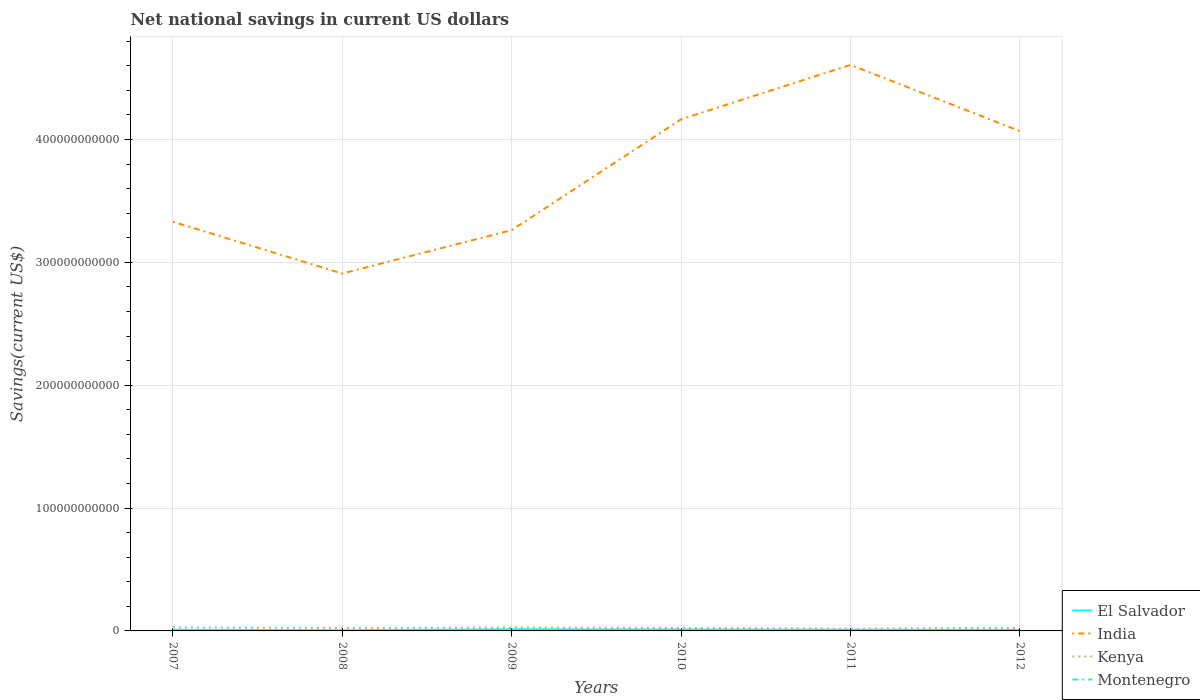Does the line corresponding to El Salvador intersect with the line corresponding to Montenegro?
Offer a terse response. No. Is the number of lines equal to the number of legend labels?
Provide a succinct answer. No. Across all years, what is the maximum net national savings in India?
Make the answer very short. 2.91e+11. What is the total net national savings in India in the graph?
Provide a succinct answer. 6.84e+09. What is the difference between the highest and the second highest net national savings in India?
Provide a succinct answer. 1.70e+11. How many lines are there?
Your answer should be very brief. 3. How many years are there in the graph?
Keep it short and to the point. 6. What is the difference between two consecutive major ticks on the Y-axis?
Provide a succinct answer. 1.00e+11. Does the graph contain any zero values?
Ensure brevity in your answer.  Yes. Does the graph contain grids?
Provide a short and direct response. Yes. How are the legend labels stacked?
Provide a succinct answer. Vertical. What is the title of the graph?
Provide a short and direct response. Net national savings in current US dollars. Does "Cyprus" appear as one of the legend labels in the graph?
Provide a succinct answer. No. What is the label or title of the X-axis?
Offer a terse response. Years. What is the label or title of the Y-axis?
Provide a succinct answer. Savings(current US$). What is the Savings(current US$) in El Salvador in 2007?
Offer a terse response. 9.61e+08. What is the Savings(current US$) of India in 2007?
Make the answer very short. 3.33e+11. What is the Savings(current US$) of Kenya in 2007?
Provide a succinct answer. 2.90e+09. What is the Savings(current US$) in Montenegro in 2007?
Offer a terse response. 0. What is the Savings(current US$) of El Salvador in 2008?
Your answer should be very brief. 5.68e+08. What is the Savings(current US$) of India in 2008?
Offer a terse response. 2.91e+11. What is the Savings(current US$) of Kenya in 2008?
Offer a terse response. 2.40e+09. What is the Savings(current US$) in Montenegro in 2008?
Your answer should be compact. 0. What is the Savings(current US$) in El Salvador in 2009?
Provide a short and direct response. 1.40e+09. What is the Savings(current US$) in India in 2009?
Provide a short and direct response. 3.26e+11. What is the Savings(current US$) in Kenya in 2009?
Offer a very short reply. 2.76e+09. What is the Savings(current US$) of Montenegro in 2009?
Keep it short and to the point. 0. What is the Savings(current US$) in El Salvador in 2010?
Give a very brief answer. 1.19e+09. What is the Savings(current US$) in India in 2010?
Give a very brief answer. 4.16e+11. What is the Savings(current US$) in Kenya in 2010?
Your response must be concise. 2.49e+09. What is the Savings(current US$) of El Salvador in 2011?
Your answer should be compact. 9.87e+08. What is the Savings(current US$) of India in 2011?
Ensure brevity in your answer.  4.61e+11. What is the Savings(current US$) of Kenya in 2011?
Your response must be concise. 1.82e+09. What is the Savings(current US$) in Montenegro in 2011?
Keep it short and to the point. 0. What is the Savings(current US$) of El Salvador in 2012?
Provide a succinct answer. 8.30e+08. What is the Savings(current US$) in India in 2012?
Keep it short and to the point. 4.07e+11. What is the Savings(current US$) in Kenya in 2012?
Your response must be concise. 2.45e+09. Across all years, what is the maximum Savings(current US$) of El Salvador?
Your answer should be compact. 1.40e+09. Across all years, what is the maximum Savings(current US$) in India?
Provide a succinct answer. 4.61e+11. Across all years, what is the maximum Savings(current US$) in Kenya?
Make the answer very short. 2.90e+09. Across all years, what is the minimum Savings(current US$) of El Salvador?
Provide a short and direct response. 5.68e+08. Across all years, what is the minimum Savings(current US$) in India?
Give a very brief answer. 2.91e+11. Across all years, what is the minimum Savings(current US$) of Kenya?
Make the answer very short. 1.82e+09. What is the total Savings(current US$) of El Salvador in the graph?
Make the answer very short. 5.94e+09. What is the total Savings(current US$) in India in the graph?
Your answer should be very brief. 2.23e+12. What is the total Savings(current US$) of Kenya in the graph?
Your answer should be very brief. 1.48e+1. What is the difference between the Savings(current US$) in El Salvador in 2007 and that in 2008?
Offer a very short reply. 3.92e+08. What is the difference between the Savings(current US$) in India in 2007 and that in 2008?
Ensure brevity in your answer.  4.22e+1. What is the difference between the Savings(current US$) of Kenya in 2007 and that in 2008?
Give a very brief answer. 4.98e+08. What is the difference between the Savings(current US$) in El Salvador in 2007 and that in 2009?
Your answer should be very brief. -4.41e+08. What is the difference between the Savings(current US$) of India in 2007 and that in 2009?
Provide a short and direct response. 6.84e+09. What is the difference between the Savings(current US$) of Kenya in 2007 and that in 2009?
Ensure brevity in your answer.  1.35e+08. What is the difference between the Savings(current US$) in El Salvador in 2007 and that in 2010?
Offer a very short reply. -2.31e+08. What is the difference between the Savings(current US$) of India in 2007 and that in 2010?
Your answer should be compact. -8.34e+1. What is the difference between the Savings(current US$) in Kenya in 2007 and that in 2010?
Your response must be concise. 4.04e+08. What is the difference between the Savings(current US$) in El Salvador in 2007 and that in 2011?
Ensure brevity in your answer.  -2.62e+07. What is the difference between the Savings(current US$) in India in 2007 and that in 2011?
Your answer should be very brief. -1.28e+11. What is the difference between the Savings(current US$) in Kenya in 2007 and that in 2011?
Your response must be concise. 1.08e+09. What is the difference between the Savings(current US$) of El Salvador in 2007 and that in 2012?
Your response must be concise. 1.30e+08. What is the difference between the Savings(current US$) of India in 2007 and that in 2012?
Your answer should be compact. -7.38e+1. What is the difference between the Savings(current US$) in Kenya in 2007 and that in 2012?
Your answer should be very brief. 4.46e+08. What is the difference between the Savings(current US$) in El Salvador in 2008 and that in 2009?
Make the answer very short. -8.33e+08. What is the difference between the Savings(current US$) in India in 2008 and that in 2009?
Keep it short and to the point. -3.53e+1. What is the difference between the Savings(current US$) in Kenya in 2008 and that in 2009?
Give a very brief answer. -3.62e+08. What is the difference between the Savings(current US$) in El Salvador in 2008 and that in 2010?
Offer a terse response. -6.24e+08. What is the difference between the Savings(current US$) of India in 2008 and that in 2010?
Your response must be concise. -1.26e+11. What is the difference between the Savings(current US$) in Kenya in 2008 and that in 2010?
Keep it short and to the point. -9.36e+07. What is the difference between the Savings(current US$) of El Salvador in 2008 and that in 2011?
Ensure brevity in your answer.  -4.18e+08. What is the difference between the Savings(current US$) in India in 2008 and that in 2011?
Give a very brief answer. -1.70e+11. What is the difference between the Savings(current US$) in Kenya in 2008 and that in 2011?
Give a very brief answer. 5.79e+08. What is the difference between the Savings(current US$) of El Salvador in 2008 and that in 2012?
Your answer should be very brief. -2.62e+08. What is the difference between the Savings(current US$) in India in 2008 and that in 2012?
Give a very brief answer. -1.16e+11. What is the difference between the Savings(current US$) in Kenya in 2008 and that in 2012?
Your answer should be compact. -5.17e+07. What is the difference between the Savings(current US$) of El Salvador in 2009 and that in 2010?
Make the answer very short. 2.10e+08. What is the difference between the Savings(current US$) of India in 2009 and that in 2010?
Your answer should be very brief. -9.02e+1. What is the difference between the Savings(current US$) in Kenya in 2009 and that in 2010?
Offer a terse response. 2.69e+08. What is the difference between the Savings(current US$) of El Salvador in 2009 and that in 2011?
Ensure brevity in your answer.  4.15e+08. What is the difference between the Savings(current US$) of India in 2009 and that in 2011?
Give a very brief answer. -1.34e+11. What is the difference between the Savings(current US$) of Kenya in 2009 and that in 2011?
Keep it short and to the point. 9.41e+08. What is the difference between the Savings(current US$) of El Salvador in 2009 and that in 2012?
Provide a short and direct response. 5.71e+08. What is the difference between the Savings(current US$) of India in 2009 and that in 2012?
Give a very brief answer. -8.06e+1. What is the difference between the Savings(current US$) of Kenya in 2009 and that in 2012?
Your answer should be very brief. 3.11e+08. What is the difference between the Savings(current US$) of El Salvador in 2010 and that in 2011?
Give a very brief answer. 2.05e+08. What is the difference between the Savings(current US$) in India in 2010 and that in 2011?
Your response must be concise. -4.42e+1. What is the difference between the Savings(current US$) in Kenya in 2010 and that in 2011?
Keep it short and to the point. 6.72e+08. What is the difference between the Savings(current US$) in El Salvador in 2010 and that in 2012?
Offer a terse response. 3.62e+08. What is the difference between the Savings(current US$) of India in 2010 and that in 2012?
Your response must be concise. 9.64e+09. What is the difference between the Savings(current US$) in Kenya in 2010 and that in 2012?
Your answer should be compact. 4.19e+07. What is the difference between the Savings(current US$) of El Salvador in 2011 and that in 2012?
Provide a short and direct response. 1.56e+08. What is the difference between the Savings(current US$) of India in 2011 and that in 2012?
Offer a terse response. 5.39e+1. What is the difference between the Savings(current US$) in Kenya in 2011 and that in 2012?
Ensure brevity in your answer.  -6.30e+08. What is the difference between the Savings(current US$) of El Salvador in 2007 and the Savings(current US$) of India in 2008?
Ensure brevity in your answer.  -2.90e+11. What is the difference between the Savings(current US$) in El Salvador in 2007 and the Savings(current US$) in Kenya in 2008?
Provide a short and direct response. -1.44e+09. What is the difference between the Savings(current US$) of India in 2007 and the Savings(current US$) of Kenya in 2008?
Provide a succinct answer. 3.31e+11. What is the difference between the Savings(current US$) in El Salvador in 2007 and the Savings(current US$) in India in 2009?
Offer a very short reply. -3.25e+11. What is the difference between the Savings(current US$) of El Salvador in 2007 and the Savings(current US$) of Kenya in 2009?
Your response must be concise. -1.80e+09. What is the difference between the Savings(current US$) of India in 2007 and the Savings(current US$) of Kenya in 2009?
Offer a very short reply. 3.30e+11. What is the difference between the Savings(current US$) in El Salvador in 2007 and the Savings(current US$) in India in 2010?
Give a very brief answer. -4.16e+11. What is the difference between the Savings(current US$) of El Salvador in 2007 and the Savings(current US$) of Kenya in 2010?
Provide a succinct answer. -1.53e+09. What is the difference between the Savings(current US$) in India in 2007 and the Savings(current US$) in Kenya in 2010?
Provide a short and direct response. 3.31e+11. What is the difference between the Savings(current US$) of El Salvador in 2007 and the Savings(current US$) of India in 2011?
Make the answer very short. -4.60e+11. What is the difference between the Savings(current US$) in El Salvador in 2007 and the Savings(current US$) in Kenya in 2011?
Your response must be concise. -8.58e+08. What is the difference between the Savings(current US$) of India in 2007 and the Savings(current US$) of Kenya in 2011?
Give a very brief answer. 3.31e+11. What is the difference between the Savings(current US$) of El Salvador in 2007 and the Savings(current US$) of India in 2012?
Provide a short and direct response. -4.06e+11. What is the difference between the Savings(current US$) in El Salvador in 2007 and the Savings(current US$) in Kenya in 2012?
Offer a very short reply. -1.49e+09. What is the difference between the Savings(current US$) of India in 2007 and the Savings(current US$) of Kenya in 2012?
Your response must be concise. 3.31e+11. What is the difference between the Savings(current US$) in El Salvador in 2008 and the Savings(current US$) in India in 2009?
Offer a terse response. -3.26e+11. What is the difference between the Savings(current US$) in El Salvador in 2008 and the Savings(current US$) in Kenya in 2009?
Make the answer very short. -2.19e+09. What is the difference between the Savings(current US$) in India in 2008 and the Savings(current US$) in Kenya in 2009?
Provide a short and direct response. 2.88e+11. What is the difference between the Savings(current US$) of El Salvador in 2008 and the Savings(current US$) of India in 2010?
Provide a succinct answer. -4.16e+11. What is the difference between the Savings(current US$) of El Salvador in 2008 and the Savings(current US$) of Kenya in 2010?
Offer a very short reply. -1.92e+09. What is the difference between the Savings(current US$) of India in 2008 and the Savings(current US$) of Kenya in 2010?
Your answer should be compact. 2.88e+11. What is the difference between the Savings(current US$) of El Salvador in 2008 and the Savings(current US$) of India in 2011?
Give a very brief answer. -4.60e+11. What is the difference between the Savings(current US$) of El Salvador in 2008 and the Savings(current US$) of Kenya in 2011?
Provide a short and direct response. -1.25e+09. What is the difference between the Savings(current US$) of India in 2008 and the Savings(current US$) of Kenya in 2011?
Ensure brevity in your answer.  2.89e+11. What is the difference between the Savings(current US$) in El Salvador in 2008 and the Savings(current US$) in India in 2012?
Make the answer very short. -4.06e+11. What is the difference between the Savings(current US$) of El Salvador in 2008 and the Savings(current US$) of Kenya in 2012?
Offer a terse response. -1.88e+09. What is the difference between the Savings(current US$) of India in 2008 and the Savings(current US$) of Kenya in 2012?
Provide a succinct answer. 2.88e+11. What is the difference between the Savings(current US$) in El Salvador in 2009 and the Savings(current US$) in India in 2010?
Offer a very short reply. -4.15e+11. What is the difference between the Savings(current US$) in El Salvador in 2009 and the Savings(current US$) in Kenya in 2010?
Ensure brevity in your answer.  -1.09e+09. What is the difference between the Savings(current US$) of India in 2009 and the Savings(current US$) of Kenya in 2010?
Keep it short and to the point. 3.24e+11. What is the difference between the Savings(current US$) in El Salvador in 2009 and the Savings(current US$) in India in 2011?
Offer a terse response. -4.59e+11. What is the difference between the Savings(current US$) in El Salvador in 2009 and the Savings(current US$) in Kenya in 2011?
Make the answer very short. -4.17e+08. What is the difference between the Savings(current US$) of India in 2009 and the Savings(current US$) of Kenya in 2011?
Provide a succinct answer. 3.24e+11. What is the difference between the Savings(current US$) in El Salvador in 2009 and the Savings(current US$) in India in 2012?
Your answer should be very brief. -4.05e+11. What is the difference between the Savings(current US$) of El Salvador in 2009 and the Savings(current US$) of Kenya in 2012?
Offer a terse response. -1.05e+09. What is the difference between the Savings(current US$) in India in 2009 and the Savings(current US$) in Kenya in 2012?
Ensure brevity in your answer.  3.24e+11. What is the difference between the Savings(current US$) in El Salvador in 2010 and the Savings(current US$) in India in 2011?
Provide a short and direct response. -4.60e+11. What is the difference between the Savings(current US$) of El Salvador in 2010 and the Savings(current US$) of Kenya in 2011?
Keep it short and to the point. -6.27e+08. What is the difference between the Savings(current US$) of India in 2010 and the Savings(current US$) of Kenya in 2011?
Your answer should be very brief. 4.15e+11. What is the difference between the Savings(current US$) of El Salvador in 2010 and the Savings(current US$) of India in 2012?
Give a very brief answer. -4.06e+11. What is the difference between the Savings(current US$) of El Salvador in 2010 and the Savings(current US$) of Kenya in 2012?
Your response must be concise. -1.26e+09. What is the difference between the Savings(current US$) of India in 2010 and the Savings(current US$) of Kenya in 2012?
Give a very brief answer. 4.14e+11. What is the difference between the Savings(current US$) in El Salvador in 2011 and the Savings(current US$) in India in 2012?
Keep it short and to the point. -4.06e+11. What is the difference between the Savings(current US$) of El Salvador in 2011 and the Savings(current US$) of Kenya in 2012?
Your answer should be compact. -1.46e+09. What is the difference between the Savings(current US$) in India in 2011 and the Savings(current US$) in Kenya in 2012?
Your response must be concise. 4.58e+11. What is the average Savings(current US$) in El Salvador per year?
Ensure brevity in your answer.  9.90e+08. What is the average Savings(current US$) of India per year?
Your response must be concise. 3.72e+11. What is the average Savings(current US$) in Kenya per year?
Your answer should be very brief. 2.47e+09. What is the average Savings(current US$) in Montenegro per year?
Keep it short and to the point. 0. In the year 2007, what is the difference between the Savings(current US$) of El Salvador and Savings(current US$) of India?
Your response must be concise. -3.32e+11. In the year 2007, what is the difference between the Savings(current US$) in El Salvador and Savings(current US$) in Kenya?
Offer a terse response. -1.93e+09. In the year 2007, what is the difference between the Savings(current US$) of India and Savings(current US$) of Kenya?
Provide a short and direct response. 3.30e+11. In the year 2008, what is the difference between the Savings(current US$) of El Salvador and Savings(current US$) of India?
Your answer should be compact. -2.90e+11. In the year 2008, what is the difference between the Savings(current US$) of El Salvador and Savings(current US$) of Kenya?
Your response must be concise. -1.83e+09. In the year 2008, what is the difference between the Savings(current US$) of India and Savings(current US$) of Kenya?
Provide a short and direct response. 2.89e+11. In the year 2009, what is the difference between the Savings(current US$) in El Salvador and Savings(current US$) in India?
Provide a short and direct response. -3.25e+11. In the year 2009, what is the difference between the Savings(current US$) in El Salvador and Savings(current US$) in Kenya?
Make the answer very short. -1.36e+09. In the year 2009, what is the difference between the Savings(current US$) in India and Savings(current US$) in Kenya?
Provide a succinct answer. 3.23e+11. In the year 2010, what is the difference between the Savings(current US$) of El Salvador and Savings(current US$) of India?
Provide a succinct answer. -4.15e+11. In the year 2010, what is the difference between the Savings(current US$) in El Salvador and Savings(current US$) in Kenya?
Provide a short and direct response. -1.30e+09. In the year 2010, what is the difference between the Savings(current US$) in India and Savings(current US$) in Kenya?
Your response must be concise. 4.14e+11. In the year 2011, what is the difference between the Savings(current US$) in El Salvador and Savings(current US$) in India?
Keep it short and to the point. -4.60e+11. In the year 2011, what is the difference between the Savings(current US$) of El Salvador and Savings(current US$) of Kenya?
Provide a short and direct response. -8.32e+08. In the year 2011, what is the difference between the Savings(current US$) in India and Savings(current US$) in Kenya?
Provide a succinct answer. 4.59e+11. In the year 2012, what is the difference between the Savings(current US$) of El Salvador and Savings(current US$) of India?
Provide a short and direct response. -4.06e+11. In the year 2012, what is the difference between the Savings(current US$) of El Salvador and Savings(current US$) of Kenya?
Offer a terse response. -1.62e+09. In the year 2012, what is the difference between the Savings(current US$) of India and Savings(current US$) of Kenya?
Provide a short and direct response. 4.04e+11. What is the ratio of the Savings(current US$) in El Salvador in 2007 to that in 2008?
Make the answer very short. 1.69. What is the ratio of the Savings(current US$) in India in 2007 to that in 2008?
Offer a very short reply. 1.14. What is the ratio of the Savings(current US$) of Kenya in 2007 to that in 2008?
Offer a very short reply. 1.21. What is the ratio of the Savings(current US$) of El Salvador in 2007 to that in 2009?
Provide a succinct answer. 0.69. What is the ratio of the Savings(current US$) of India in 2007 to that in 2009?
Your answer should be compact. 1.02. What is the ratio of the Savings(current US$) of Kenya in 2007 to that in 2009?
Keep it short and to the point. 1.05. What is the ratio of the Savings(current US$) in El Salvador in 2007 to that in 2010?
Give a very brief answer. 0.81. What is the ratio of the Savings(current US$) in India in 2007 to that in 2010?
Make the answer very short. 0.8. What is the ratio of the Savings(current US$) of Kenya in 2007 to that in 2010?
Offer a very short reply. 1.16. What is the ratio of the Savings(current US$) in El Salvador in 2007 to that in 2011?
Offer a terse response. 0.97. What is the ratio of the Savings(current US$) in India in 2007 to that in 2011?
Make the answer very short. 0.72. What is the ratio of the Savings(current US$) in Kenya in 2007 to that in 2011?
Give a very brief answer. 1.59. What is the ratio of the Savings(current US$) of El Salvador in 2007 to that in 2012?
Your response must be concise. 1.16. What is the ratio of the Savings(current US$) in India in 2007 to that in 2012?
Provide a short and direct response. 0.82. What is the ratio of the Savings(current US$) in Kenya in 2007 to that in 2012?
Give a very brief answer. 1.18. What is the ratio of the Savings(current US$) of El Salvador in 2008 to that in 2009?
Provide a succinct answer. 0.41. What is the ratio of the Savings(current US$) of India in 2008 to that in 2009?
Ensure brevity in your answer.  0.89. What is the ratio of the Savings(current US$) of Kenya in 2008 to that in 2009?
Your answer should be very brief. 0.87. What is the ratio of the Savings(current US$) of El Salvador in 2008 to that in 2010?
Your response must be concise. 0.48. What is the ratio of the Savings(current US$) in India in 2008 to that in 2010?
Provide a succinct answer. 0.7. What is the ratio of the Savings(current US$) in Kenya in 2008 to that in 2010?
Provide a short and direct response. 0.96. What is the ratio of the Savings(current US$) in El Salvador in 2008 to that in 2011?
Provide a succinct answer. 0.58. What is the ratio of the Savings(current US$) in India in 2008 to that in 2011?
Keep it short and to the point. 0.63. What is the ratio of the Savings(current US$) of Kenya in 2008 to that in 2011?
Give a very brief answer. 1.32. What is the ratio of the Savings(current US$) of El Salvador in 2008 to that in 2012?
Ensure brevity in your answer.  0.68. What is the ratio of the Savings(current US$) in India in 2008 to that in 2012?
Keep it short and to the point. 0.72. What is the ratio of the Savings(current US$) of Kenya in 2008 to that in 2012?
Your answer should be very brief. 0.98. What is the ratio of the Savings(current US$) in El Salvador in 2009 to that in 2010?
Give a very brief answer. 1.18. What is the ratio of the Savings(current US$) in India in 2009 to that in 2010?
Provide a succinct answer. 0.78. What is the ratio of the Savings(current US$) in Kenya in 2009 to that in 2010?
Offer a terse response. 1.11. What is the ratio of the Savings(current US$) of El Salvador in 2009 to that in 2011?
Your response must be concise. 1.42. What is the ratio of the Savings(current US$) in India in 2009 to that in 2011?
Offer a very short reply. 0.71. What is the ratio of the Savings(current US$) in Kenya in 2009 to that in 2011?
Give a very brief answer. 1.52. What is the ratio of the Savings(current US$) in El Salvador in 2009 to that in 2012?
Keep it short and to the point. 1.69. What is the ratio of the Savings(current US$) of India in 2009 to that in 2012?
Keep it short and to the point. 0.8. What is the ratio of the Savings(current US$) in Kenya in 2009 to that in 2012?
Provide a short and direct response. 1.13. What is the ratio of the Savings(current US$) in El Salvador in 2010 to that in 2011?
Give a very brief answer. 1.21. What is the ratio of the Savings(current US$) of India in 2010 to that in 2011?
Provide a succinct answer. 0.9. What is the ratio of the Savings(current US$) in Kenya in 2010 to that in 2011?
Keep it short and to the point. 1.37. What is the ratio of the Savings(current US$) of El Salvador in 2010 to that in 2012?
Make the answer very short. 1.44. What is the ratio of the Savings(current US$) of India in 2010 to that in 2012?
Keep it short and to the point. 1.02. What is the ratio of the Savings(current US$) in Kenya in 2010 to that in 2012?
Give a very brief answer. 1.02. What is the ratio of the Savings(current US$) of El Salvador in 2011 to that in 2012?
Give a very brief answer. 1.19. What is the ratio of the Savings(current US$) in India in 2011 to that in 2012?
Offer a terse response. 1.13. What is the ratio of the Savings(current US$) in Kenya in 2011 to that in 2012?
Ensure brevity in your answer.  0.74. What is the difference between the highest and the second highest Savings(current US$) in El Salvador?
Your answer should be compact. 2.10e+08. What is the difference between the highest and the second highest Savings(current US$) of India?
Make the answer very short. 4.42e+1. What is the difference between the highest and the second highest Savings(current US$) in Kenya?
Keep it short and to the point. 1.35e+08. What is the difference between the highest and the lowest Savings(current US$) in El Salvador?
Offer a very short reply. 8.33e+08. What is the difference between the highest and the lowest Savings(current US$) of India?
Offer a terse response. 1.70e+11. What is the difference between the highest and the lowest Savings(current US$) in Kenya?
Your response must be concise. 1.08e+09. 